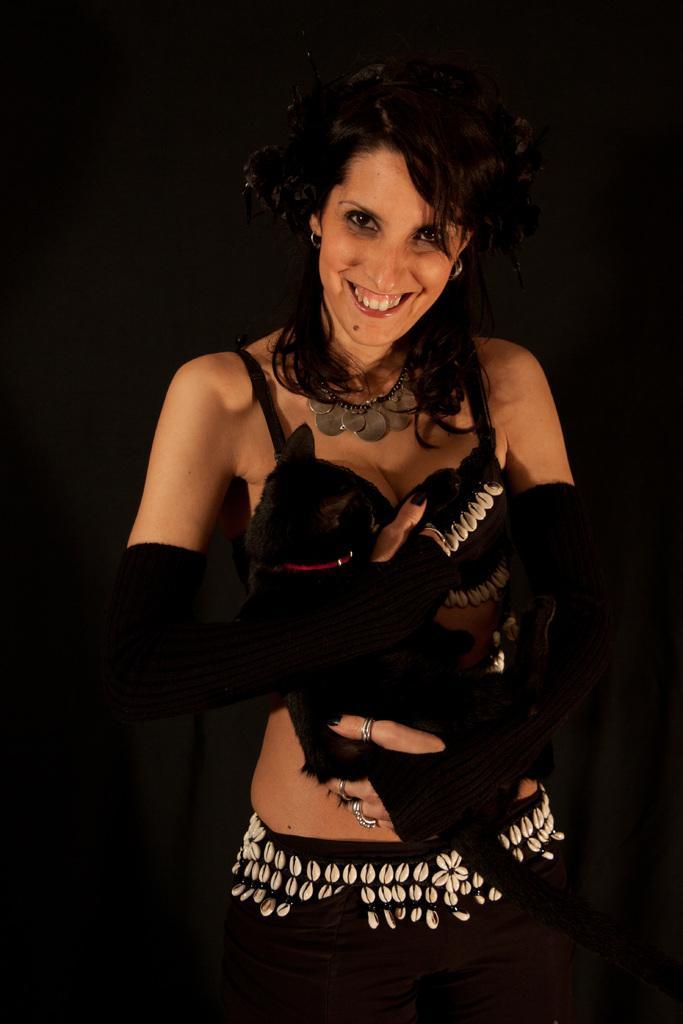How would you summarize this image in a sentence or two? In the picture we can see a woman standing and smiling, she is with black top and black gloves and behind her we can see dark. 